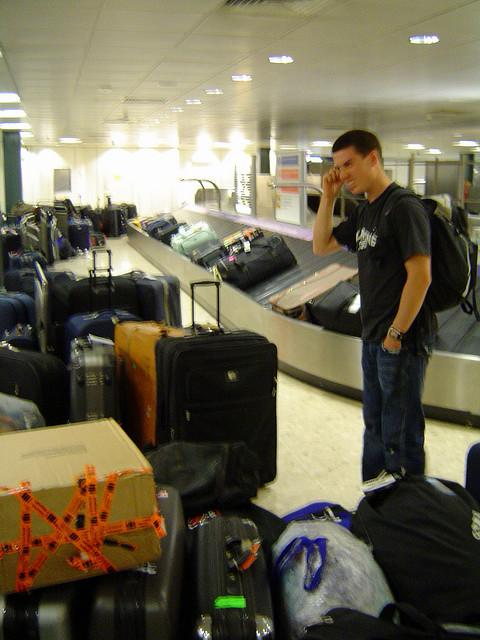What kind of reaction the person shows?

Choices:
A) smiling
B) laughing
C) ordering
D) confusion confusion 